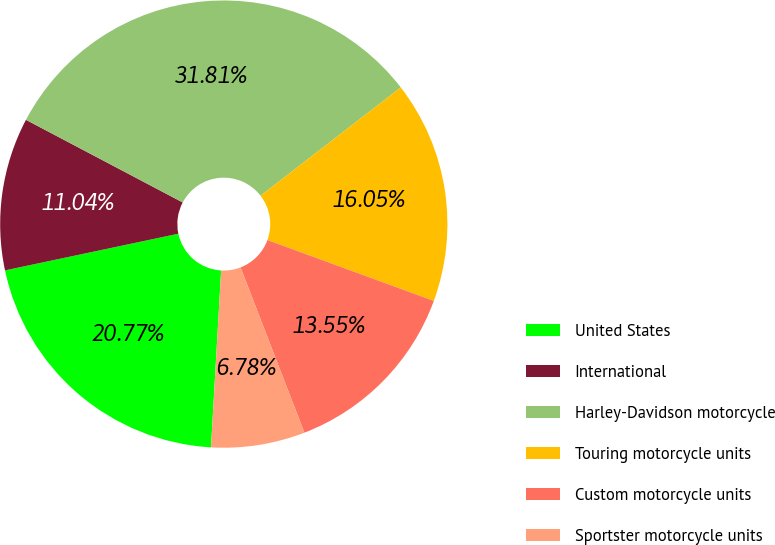Convert chart to OTSL. <chart><loc_0><loc_0><loc_500><loc_500><pie_chart><fcel>United States<fcel>International<fcel>Harley-Davidson motorcycle<fcel>Touring motorcycle units<fcel>Custom motorcycle units<fcel>Sportster motorcycle units<nl><fcel>20.77%<fcel>11.04%<fcel>31.81%<fcel>16.05%<fcel>13.55%<fcel>6.78%<nl></chart> 